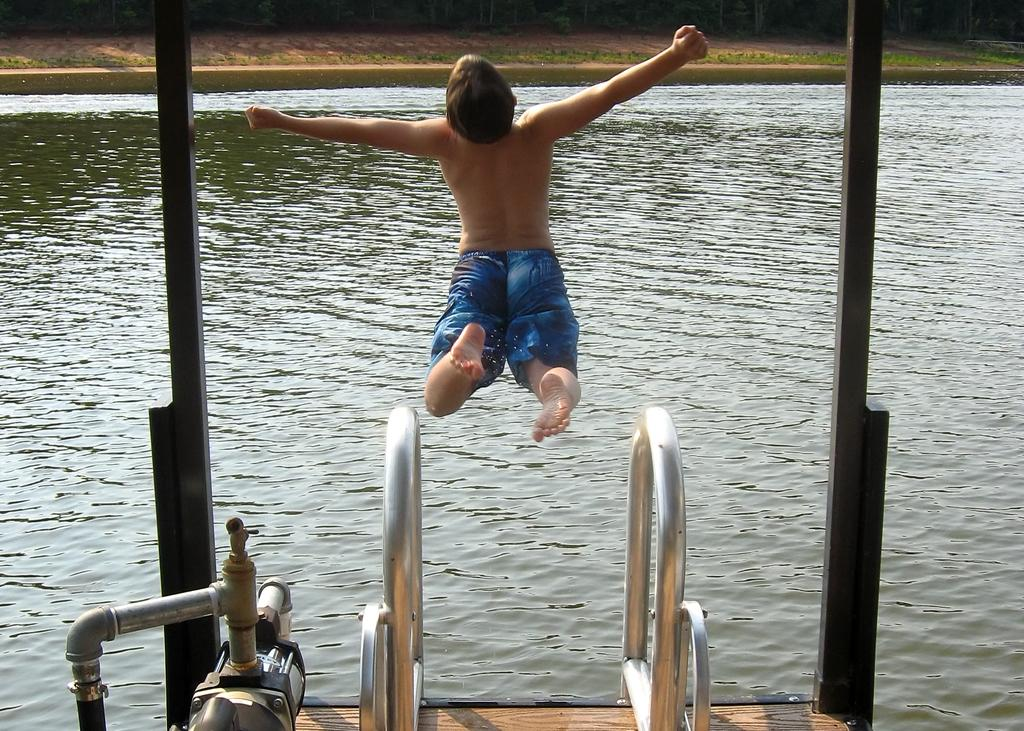Who is the main subject in the image? There is a boy in the center of the image. What is the boy about to do? The boy is about to jump in the water. What is the primary element in the image? There is water in the center of the image. How many kittens are sitting on the furniture in the image? There is no furniture or kittens present in the image. 